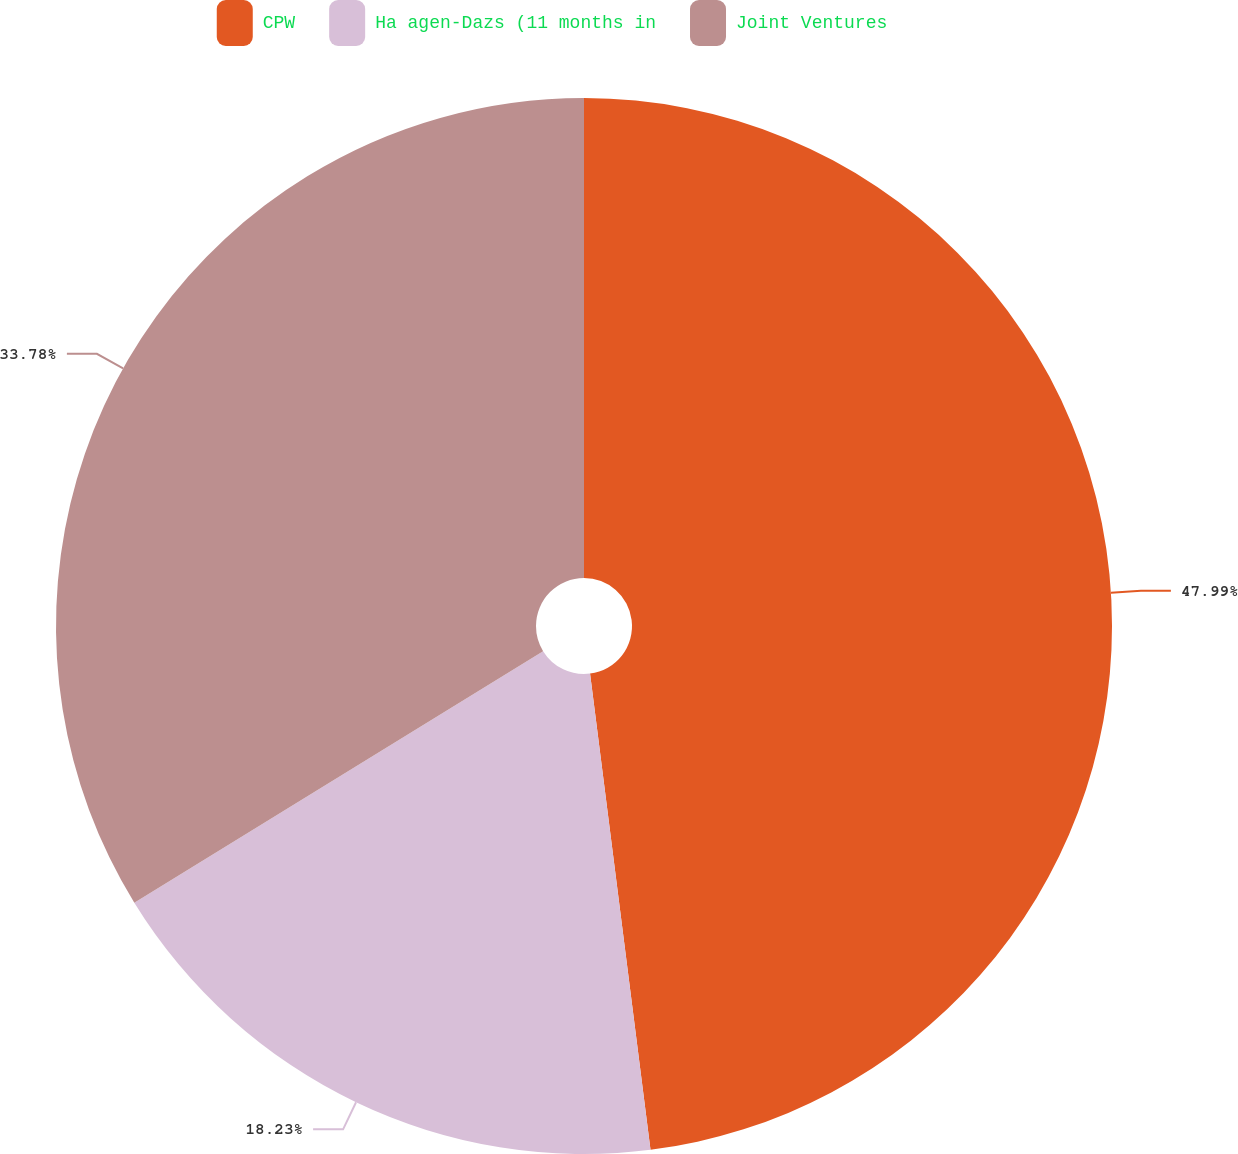Convert chart. <chart><loc_0><loc_0><loc_500><loc_500><pie_chart><fcel>CPW<fcel>Ha agen-Dazs (11 months in<fcel>Joint Ventures<nl><fcel>47.99%<fcel>18.23%<fcel>33.78%<nl></chart> 